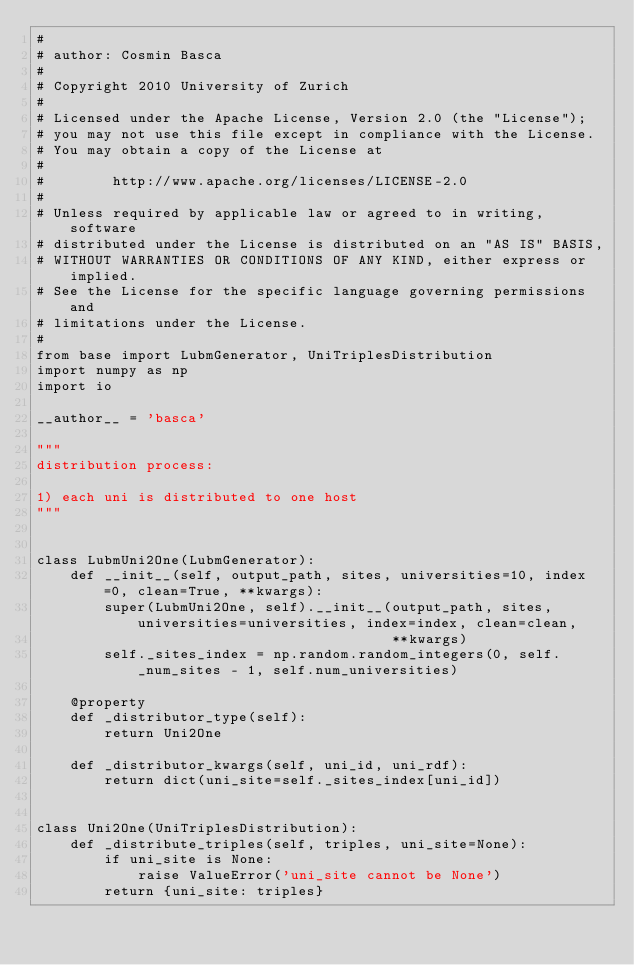Convert code to text. <code><loc_0><loc_0><loc_500><loc_500><_Python_>#
# author: Cosmin Basca
#
# Copyright 2010 University of Zurich
#
# Licensed under the Apache License, Version 2.0 (the "License");
# you may not use this file except in compliance with the License.
# You may obtain a copy of the License at
#
#        http://www.apache.org/licenses/LICENSE-2.0
#
# Unless required by applicable law or agreed to in writing, software
# distributed under the License is distributed on an "AS IS" BASIS,
# WITHOUT WARRANTIES OR CONDITIONS OF ANY KIND, either express or implied.
# See the License for the specific language governing permissions and
# limitations under the License.
#
from base import LubmGenerator, UniTriplesDistribution
import numpy as np
import io

__author__ = 'basca'

"""
distribution process:

1) each uni is distributed to one host
"""


class LubmUni2One(LubmGenerator):
    def __init__(self, output_path, sites, universities=10, index=0, clean=True, **kwargs):
        super(LubmUni2One, self).__init__(output_path, sites, universities=universities, index=index, clean=clean,
                                          **kwargs)
        self._sites_index = np.random.random_integers(0, self._num_sites - 1, self.num_universities)

    @property
    def _distributor_type(self):
        return Uni2One

    def _distributor_kwargs(self, uni_id, uni_rdf):
        return dict(uni_site=self._sites_index[uni_id])


class Uni2One(UniTriplesDistribution):
    def _distribute_triples(self, triples, uni_site=None):
        if uni_site is None:
            raise ValueError('uni_site cannot be None')
        return {uni_site: triples}</code> 